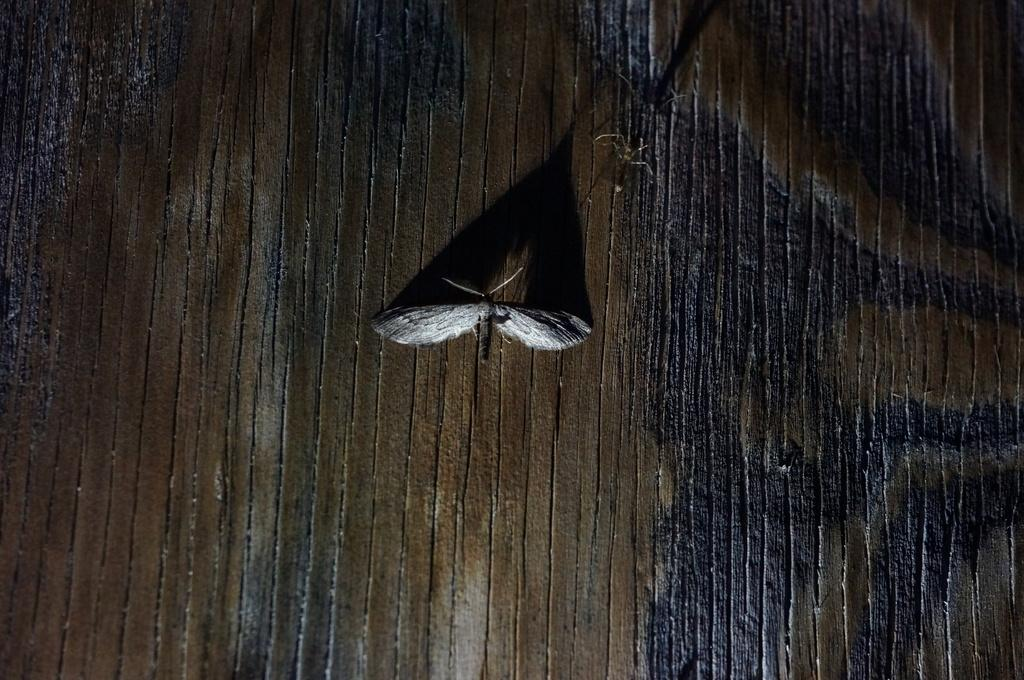What is the main subject of the image? There is an insect in the image. Where is the insect located in the image? The insect is in the center of the image. What type of vessel is being used by the jellyfish in the image? There is no jellyfish or vessel present in the image; it features an insect in the center. 